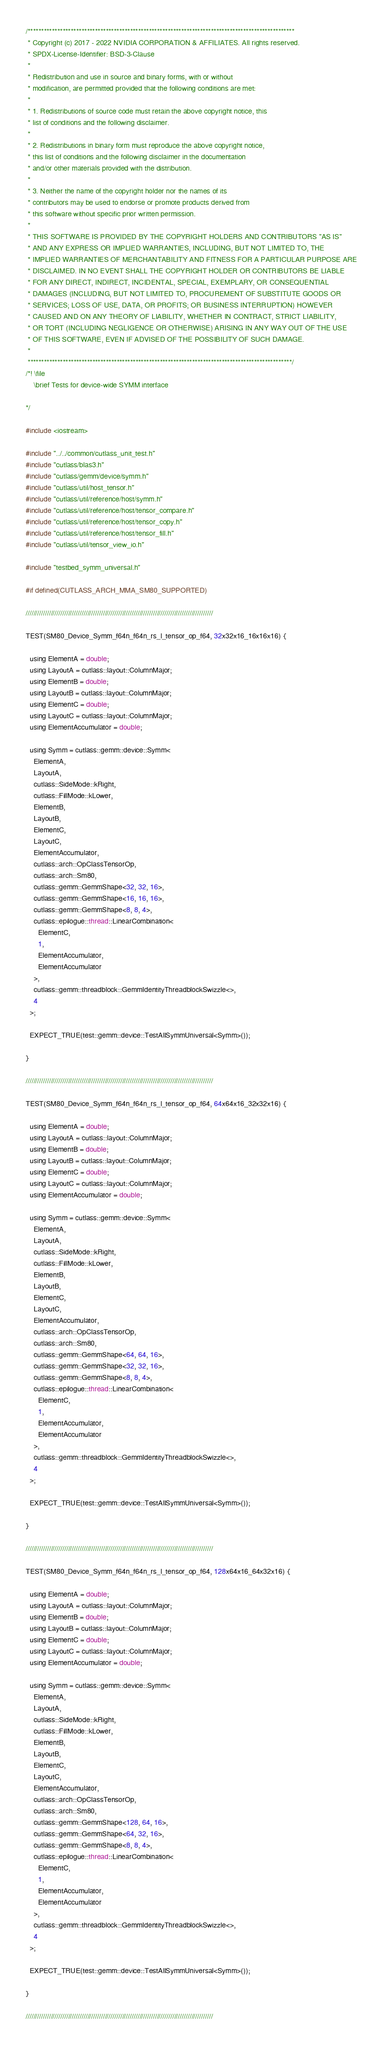<code> <loc_0><loc_0><loc_500><loc_500><_Cuda_>/***************************************************************************************************
 * Copyright (c) 2017 - 2022 NVIDIA CORPORATION & AFFILIATES. All rights reserved.
 * SPDX-License-Identifier: BSD-3-Clause
 *
 * Redistribution and use in source and binary forms, with or without
 * modification, are permitted provided that the following conditions are met:
 *
 * 1. Redistributions of source code must retain the above copyright notice, this
 * list of conditions and the following disclaimer.
 *
 * 2. Redistributions in binary form must reproduce the above copyright notice,
 * this list of conditions and the following disclaimer in the documentation
 * and/or other materials provided with the distribution.
 *
 * 3. Neither the name of the copyright holder nor the names of its
 * contributors may be used to endorse or promote products derived from
 * this software without specific prior written permission.
 *
 * THIS SOFTWARE IS PROVIDED BY THE COPYRIGHT HOLDERS AND CONTRIBUTORS "AS IS"
 * AND ANY EXPRESS OR IMPLIED WARRANTIES, INCLUDING, BUT NOT LIMITED TO, THE
 * IMPLIED WARRANTIES OF MERCHANTABILITY AND FITNESS FOR A PARTICULAR PURPOSE ARE
 * DISCLAIMED. IN NO EVENT SHALL THE COPYRIGHT HOLDER OR CONTRIBUTORS BE LIABLE
 * FOR ANY DIRECT, INDIRECT, INCIDENTAL, SPECIAL, EXEMPLARY, OR CONSEQUENTIAL
 * DAMAGES (INCLUDING, BUT NOT LIMITED TO, PROCUREMENT OF SUBSTITUTE GOODS OR
 * SERVICES; LOSS OF USE, DATA, OR PROFITS; OR BUSINESS INTERRUPTION) HOWEVER
 * CAUSED AND ON ANY THEORY OF LIABILITY, WHETHER IN CONTRACT, STRICT LIABILITY,
 * OR TORT (INCLUDING NEGLIGENCE OR OTHERWISE) ARISING IN ANY WAY OUT OF THE USE
 * OF THIS SOFTWARE, EVEN IF ADVISED OF THE POSSIBILITY OF SUCH DAMAGE.
 *
 **************************************************************************************************/
/*! \file
    \brief Tests for device-wide SYMM interface
  
*/

#include <iostream>

#include "../../common/cutlass_unit_test.h"
#include "cutlass/blas3.h"
#include "cutlass/gemm/device/symm.h"
#include "cutlass/util/host_tensor.h"
#include "cutlass/util/reference/host/symm.h"
#include "cutlass/util/reference/host/tensor_compare.h"
#include "cutlass/util/reference/host/tensor_copy.h"
#include "cutlass/util/reference/host/tensor_fill.h"
#include "cutlass/util/tensor_view_io.h"

#include "testbed_symm_universal.h"

#if defined(CUTLASS_ARCH_MMA_SM80_SUPPORTED)

/////////////////////////////////////////////////////////////////////////////////////////////////

TEST(SM80_Device_Symm_f64n_f64n_rs_l_tensor_op_f64, 32x32x16_16x16x16) {

  using ElementA = double;
  using LayoutA = cutlass::layout::ColumnMajor;
  using ElementB = double;
  using LayoutB = cutlass::layout::ColumnMajor;
  using ElementC = double;
  using LayoutC = cutlass::layout::ColumnMajor;
  using ElementAccumulator = double;

  using Symm = cutlass::gemm::device::Symm<
    ElementA,
    LayoutA,
    cutlass::SideMode::kRight,
    cutlass::FillMode::kLower,
    ElementB,
    LayoutB,
    ElementC,
    LayoutC,
    ElementAccumulator,
    cutlass::arch::OpClassTensorOp,
    cutlass::arch::Sm80,
    cutlass::gemm::GemmShape<32, 32, 16>,
    cutlass::gemm::GemmShape<16, 16, 16>,
    cutlass::gemm::GemmShape<8, 8, 4>,
    cutlass::epilogue::thread::LinearCombination<
      ElementC,
      1,
      ElementAccumulator,
      ElementAccumulator
    >,
    cutlass::gemm::threadblock::GemmIdentityThreadblockSwizzle<>,
    4
  >;

  EXPECT_TRUE(test::gemm::device::TestAllSymmUniversal<Symm>());

}

/////////////////////////////////////////////////////////////////////////////////////////////////

TEST(SM80_Device_Symm_f64n_f64n_rs_l_tensor_op_f64, 64x64x16_32x32x16) {

  using ElementA = double;
  using LayoutA = cutlass::layout::ColumnMajor;
  using ElementB = double;
  using LayoutB = cutlass::layout::ColumnMajor;
  using ElementC = double;
  using LayoutC = cutlass::layout::ColumnMajor;
  using ElementAccumulator = double;

  using Symm = cutlass::gemm::device::Symm<
    ElementA,
    LayoutA,
    cutlass::SideMode::kRight,
    cutlass::FillMode::kLower,
    ElementB,
    LayoutB,
    ElementC,
    LayoutC,
    ElementAccumulator,
    cutlass::arch::OpClassTensorOp,
    cutlass::arch::Sm80,
    cutlass::gemm::GemmShape<64, 64, 16>,
    cutlass::gemm::GemmShape<32, 32, 16>,
    cutlass::gemm::GemmShape<8, 8, 4>,
    cutlass::epilogue::thread::LinearCombination<
      ElementC,
      1,
      ElementAccumulator,
      ElementAccumulator
    >,
    cutlass::gemm::threadblock::GemmIdentityThreadblockSwizzle<>,
    4
  >;

  EXPECT_TRUE(test::gemm::device::TestAllSymmUniversal<Symm>());

}

/////////////////////////////////////////////////////////////////////////////////////////////////

TEST(SM80_Device_Symm_f64n_f64n_rs_l_tensor_op_f64, 128x64x16_64x32x16) {

  using ElementA = double;
  using LayoutA = cutlass::layout::ColumnMajor;
  using ElementB = double;
  using LayoutB = cutlass::layout::ColumnMajor;
  using ElementC = double;
  using LayoutC = cutlass::layout::ColumnMajor;
  using ElementAccumulator = double;

  using Symm = cutlass::gemm::device::Symm<
    ElementA,
    LayoutA,
    cutlass::SideMode::kRight,
    cutlass::FillMode::kLower,
    ElementB,
    LayoutB,
    ElementC,
    LayoutC,
    ElementAccumulator,
    cutlass::arch::OpClassTensorOp,
    cutlass::arch::Sm80,
    cutlass::gemm::GemmShape<128, 64, 16>,
    cutlass::gemm::GemmShape<64, 32, 16>,
    cutlass::gemm::GemmShape<8, 8, 4>,
    cutlass::epilogue::thread::LinearCombination<
      ElementC,
      1,
      ElementAccumulator,
      ElementAccumulator
    >,
    cutlass::gemm::threadblock::GemmIdentityThreadblockSwizzle<>,
    4
  >;

  EXPECT_TRUE(test::gemm::device::TestAllSymmUniversal<Symm>());

}

/////////////////////////////////////////////////////////////////////////////////////////////////
</code> 